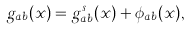Convert formula to latex. <formula><loc_0><loc_0><loc_500><loc_500>g _ { a b } ( x ) = g _ { a b } ^ { s } ( x ) + \phi _ { a b } ( x ) ,</formula> 